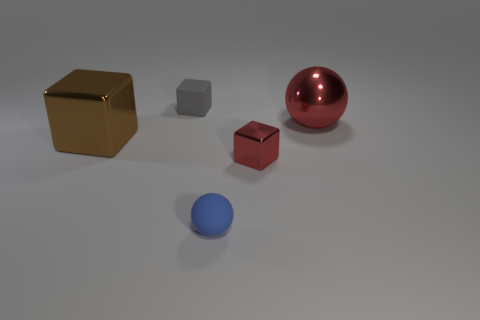Subtract all metal blocks. How many blocks are left? 1 Add 5 red objects. How many objects exist? 10 Subtract all blue matte cubes. Subtract all red blocks. How many objects are left? 4 Add 3 small blue rubber things. How many small blue rubber things are left? 4 Add 1 large brown metal things. How many large brown metal things exist? 2 Subtract 1 gray cubes. How many objects are left? 4 Subtract all spheres. How many objects are left? 3 